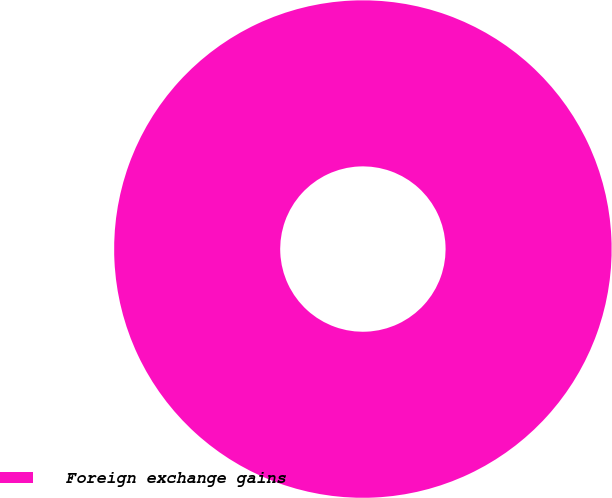Convert chart to OTSL. <chart><loc_0><loc_0><loc_500><loc_500><pie_chart><fcel>Foreign exchange gains<nl><fcel>100.0%<nl></chart> 